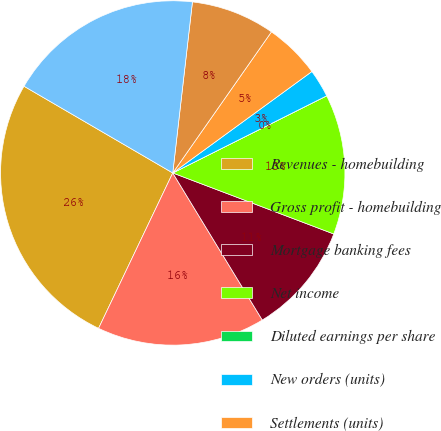Convert chart to OTSL. <chart><loc_0><loc_0><loc_500><loc_500><pie_chart><fcel>Revenues - homebuilding<fcel>Gross profit - homebuilding<fcel>Mortgage banking fees<fcel>Net income<fcel>Diluted earnings per share<fcel>New orders (units)<fcel>Settlements (units)<fcel>Backlog end of period (units)<fcel>Loans closed<nl><fcel>26.31%<fcel>15.79%<fcel>10.53%<fcel>13.16%<fcel>0.0%<fcel>2.63%<fcel>5.26%<fcel>7.89%<fcel>18.42%<nl></chart> 